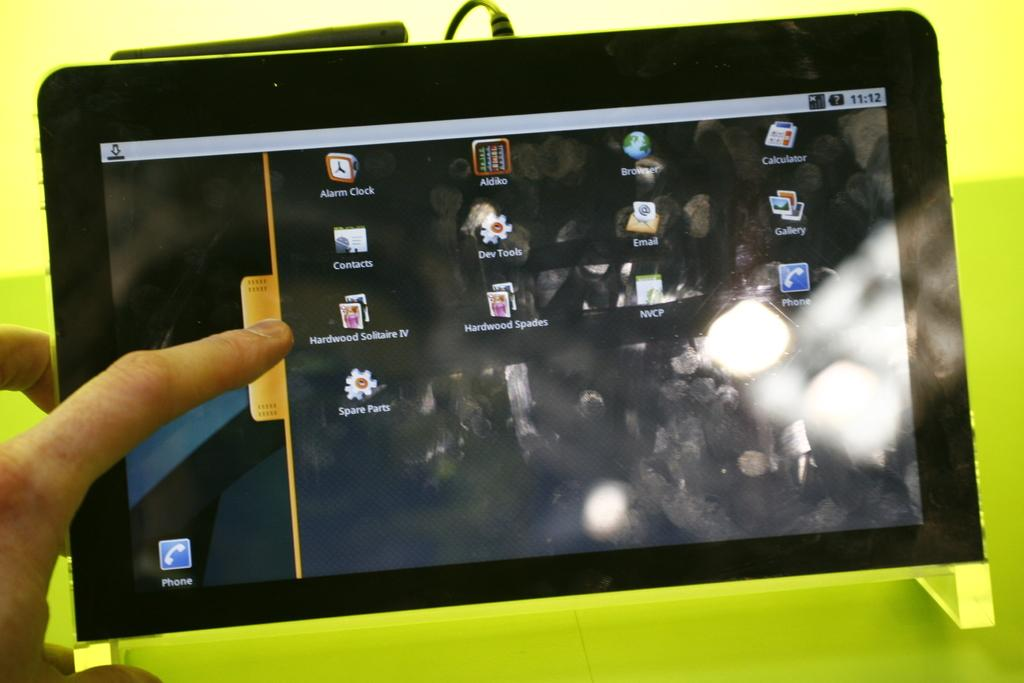What is the main object in the image? There is a gadget in the image. What is the color of the gadget's surface? The gadget has a parrot green color surface. What is connected to the gadget in the image? There is a cable wire in the image. Whose fingers are visible in the image? Human fingers are visible in the image. What type of arch can be seen in the image? There is no arch present in the image. Who is the representative of the gadget in the image? The image does not depict a representative for the gadget. How many lizards are visible in the image? There are no lizards present in the image. 